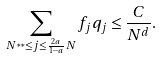<formula> <loc_0><loc_0><loc_500><loc_500>\sum _ { N ^ { * * } \leq j \leq \frac { 2 a } { 1 - a } N } f _ { j } q _ { j } \leq \frac { C } { N ^ { d } } .</formula> 